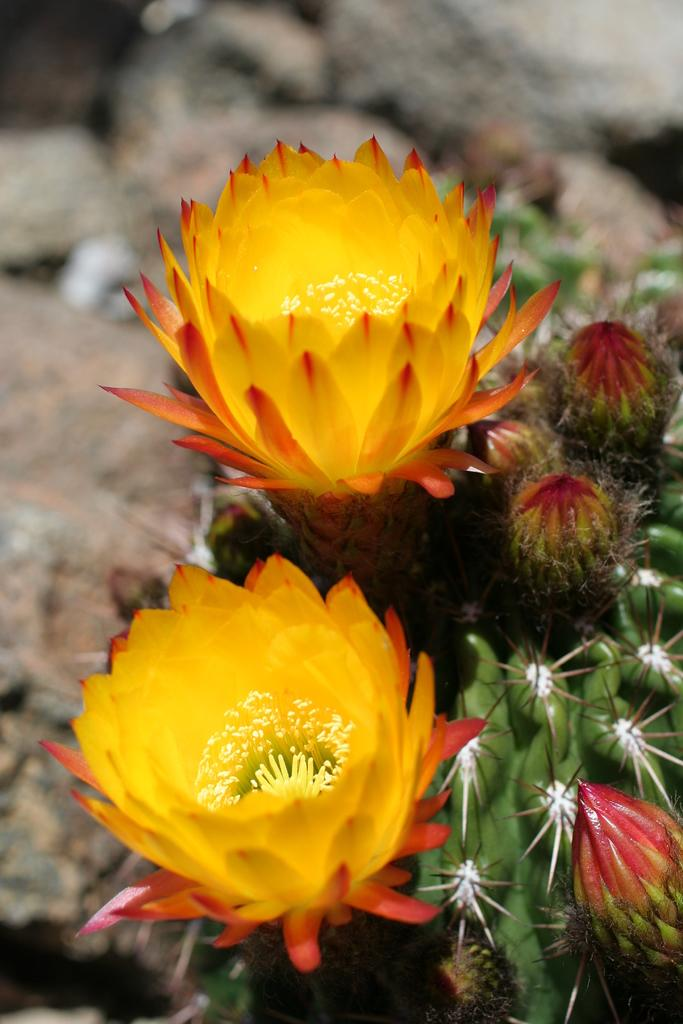What type of plants are in the image? There are two large cactus plants in the image. What features can be observed on the cactus plants? The cactus plants have flowers and thorns. What effect does the squirrel have on the cactus plants in the image? There is no squirrel present in the image, so it cannot have any effect on the cactus plants. 